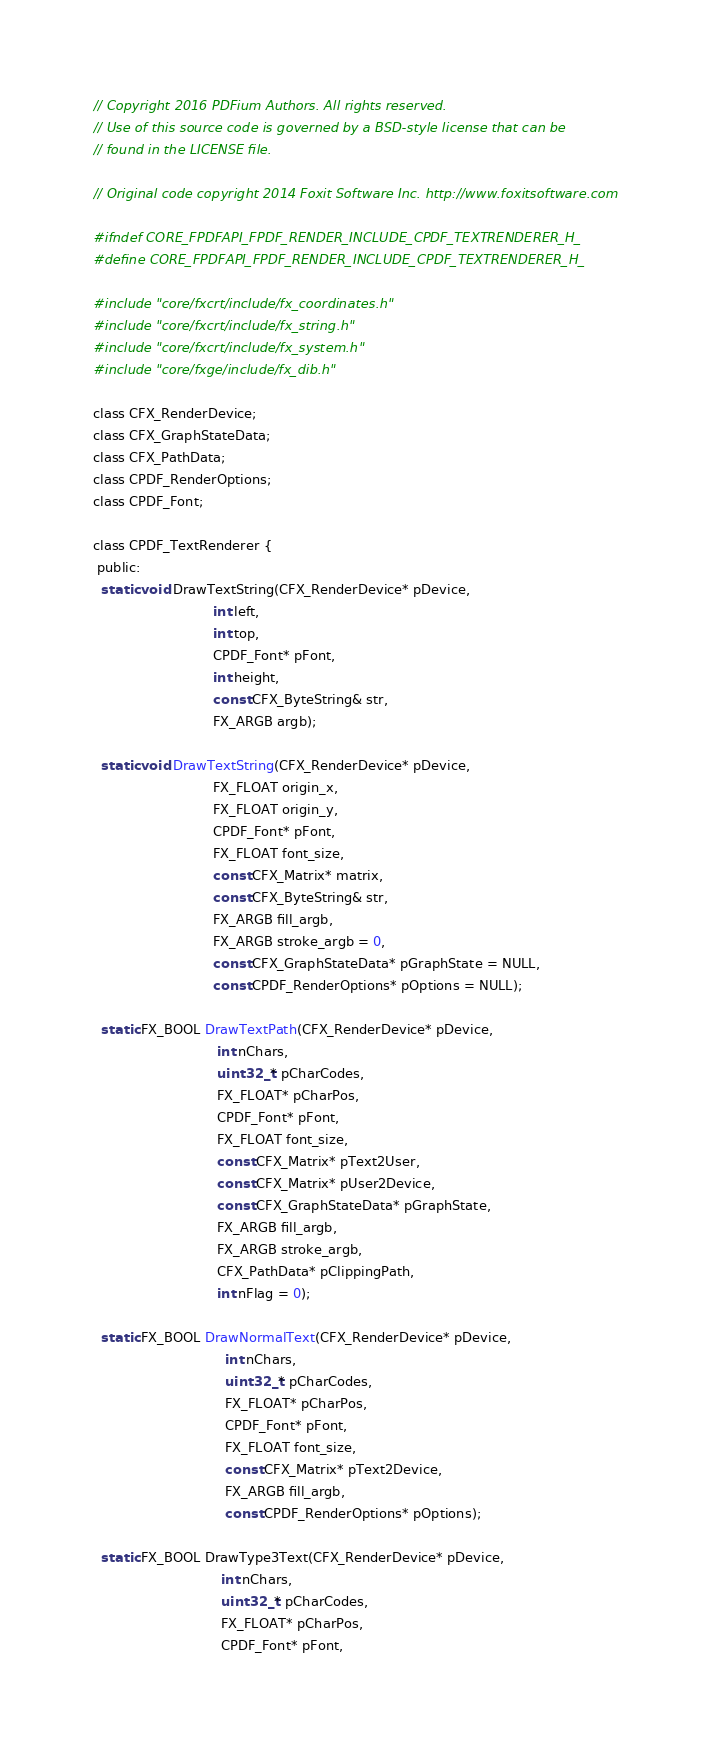<code> <loc_0><loc_0><loc_500><loc_500><_C_>// Copyright 2016 PDFium Authors. All rights reserved.
// Use of this source code is governed by a BSD-style license that can be
// found in the LICENSE file.

// Original code copyright 2014 Foxit Software Inc. http://www.foxitsoftware.com

#ifndef CORE_FPDFAPI_FPDF_RENDER_INCLUDE_CPDF_TEXTRENDERER_H_
#define CORE_FPDFAPI_FPDF_RENDER_INCLUDE_CPDF_TEXTRENDERER_H_

#include "core/fxcrt/include/fx_coordinates.h"
#include "core/fxcrt/include/fx_string.h"
#include "core/fxcrt/include/fx_system.h"
#include "core/fxge/include/fx_dib.h"

class CFX_RenderDevice;
class CFX_GraphStateData;
class CFX_PathData;
class CPDF_RenderOptions;
class CPDF_Font;

class CPDF_TextRenderer {
 public:
  static void DrawTextString(CFX_RenderDevice* pDevice,
                             int left,
                             int top,
                             CPDF_Font* pFont,
                             int height,
                             const CFX_ByteString& str,
                             FX_ARGB argb);

  static void DrawTextString(CFX_RenderDevice* pDevice,
                             FX_FLOAT origin_x,
                             FX_FLOAT origin_y,
                             CPDF_Font* pFont,
                             FX_FLOAT font_size,
                             const CFX_Matrix* matrix,
                             const CFX_ByteString& str,
                             FX_ARGB fill_argb,
                             FX_ARGB stroke_argb = 0,
                             const CFX_GraphStateData* pGraphState = NULL,
                             const CPDF_RenderOptions* pOptions = NULL);

  static FX_BOOL DrawTextPath(CFX_RenderDevice* pDevice,
                              int nChars,
                              uint32_t* pCharCodes,
                              FX_FLOAT* pCharPos,
                              CPDF_Font* pFont,
                              FX_FLOAT font_size,
                              const CFX_Matrix* pText2User,
                              const CFX_Matrix* pUser2Device,
                              const CFX_GraphStateData* pGraphState,
                              FX_ARGB fill_argb,
                              FX_ARGB stroke_argb,
                              CFX_PathData* pClippingPath,
                              int nFlag = 0);

  static FX_BOOL DrawNormalText(CFX_RenderDevice* pDevice,
                                int nChars,
                                uint32_t* pCharCodes,
                                FX_FLOAT* pCharPos,
                                CPDF_Font* pFont,
                                FX_FLOAT font_size,
                                const CFX_Matrix* pText2Device,
                                FX_ARGB fill_argb,
                                const CPDF_RenderOptions* pOptions);

  static FX_BOOL DrawType3Text(CFX_RenderDevice* pDevice,
                               int nChars,
                               uint32_t* pCharCodes,
                               FX_FLOAT* pCharPos,
                               CPDF_Font* pFont,</code> 